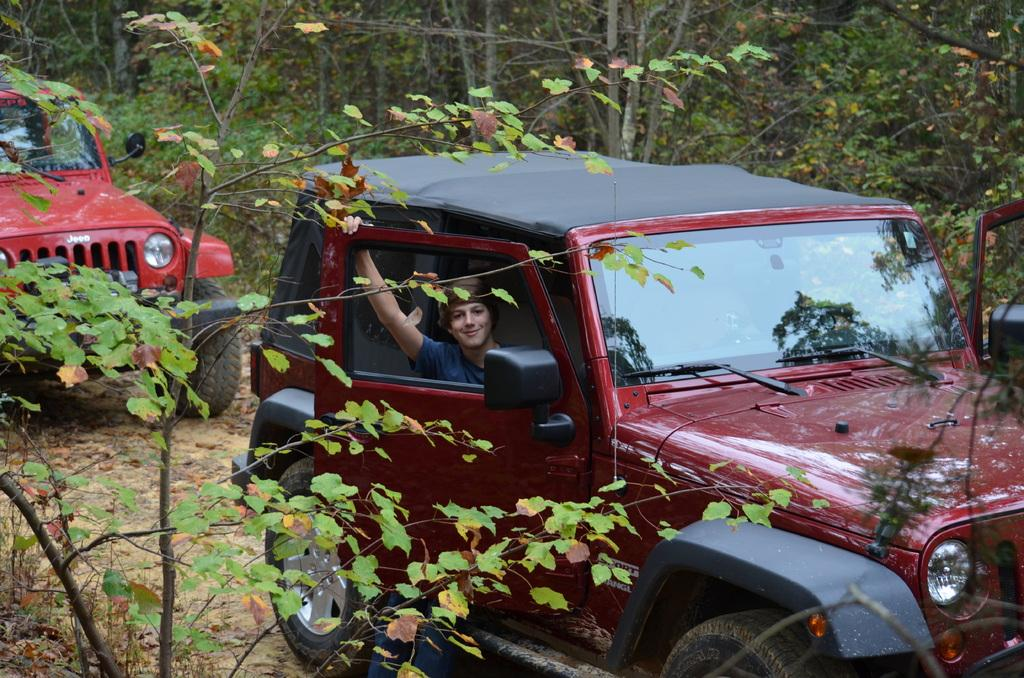What types of objects are present in the image? There are vehicles and a person in the image. Can you describe the environment in the image? There are trees in the background of the image, and there is a tree on the left side of the image. What type of pie is being served to the girl in the image? There is no girl or pie present in the image. 